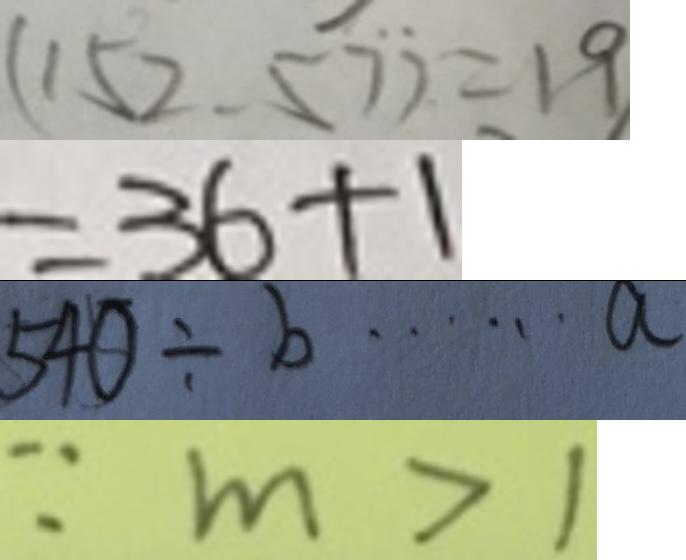<formula> <loc_0><loc_0><loc_500><loc_500>( 1 5 2 . 5 7 ) = 1 9 
 = 3 6 + 1 
 5 4 0 \div b \cdots a 
 \because m > 1</formula> 